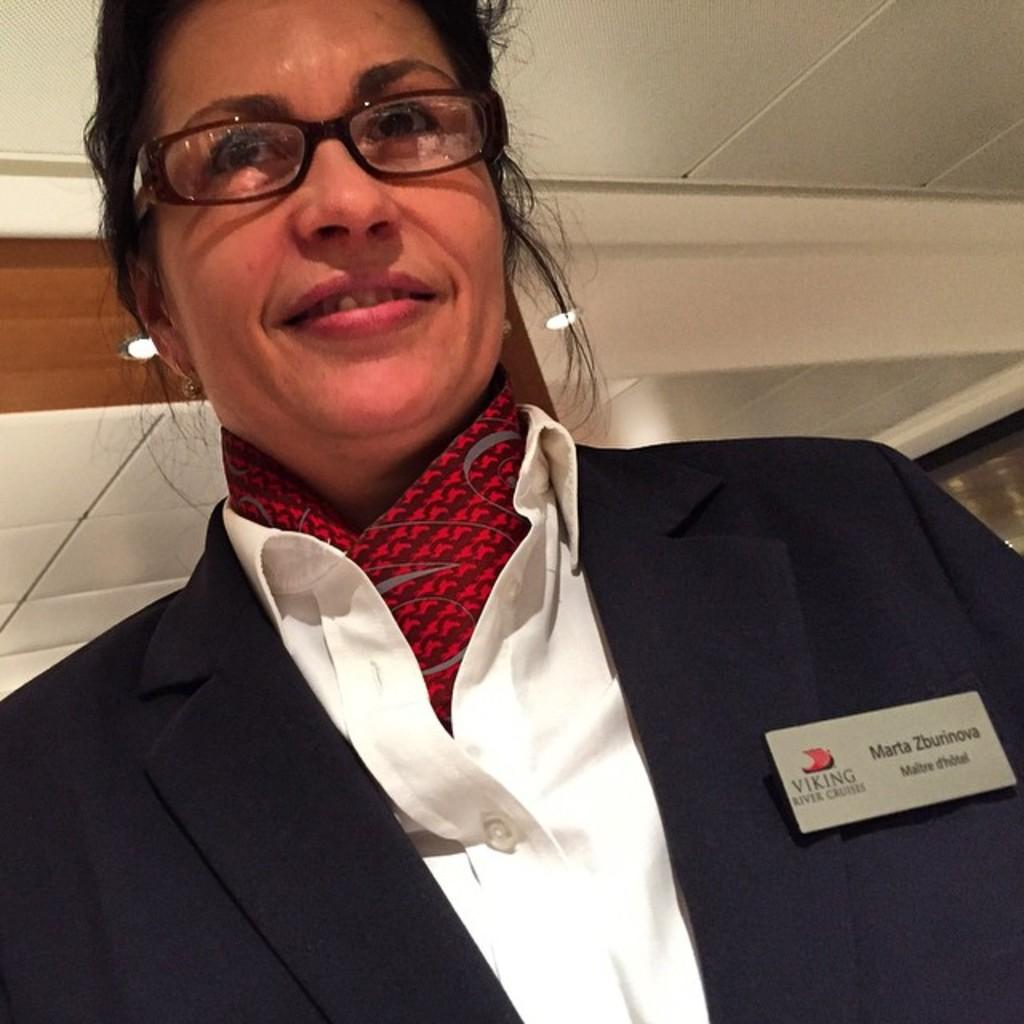Who is the main subject in the image? There is a lady in the image. What is the lady wearing in the image? The lady is wearing a suit, a scarf, and specks (glasses). Can you describe any additional details about the lady's attire? There is a name plate on her suit. What can be seen in the background of the image? The ceiling is visible in the image, along with lights. How many horses are participating in the competition in the image? There are no horses or competition present in the image; it features a lady wearing a suit, scarf, and specks with a name plate on her suit. What type of bird can be seen flying in the image? There are no birds present in the image. 